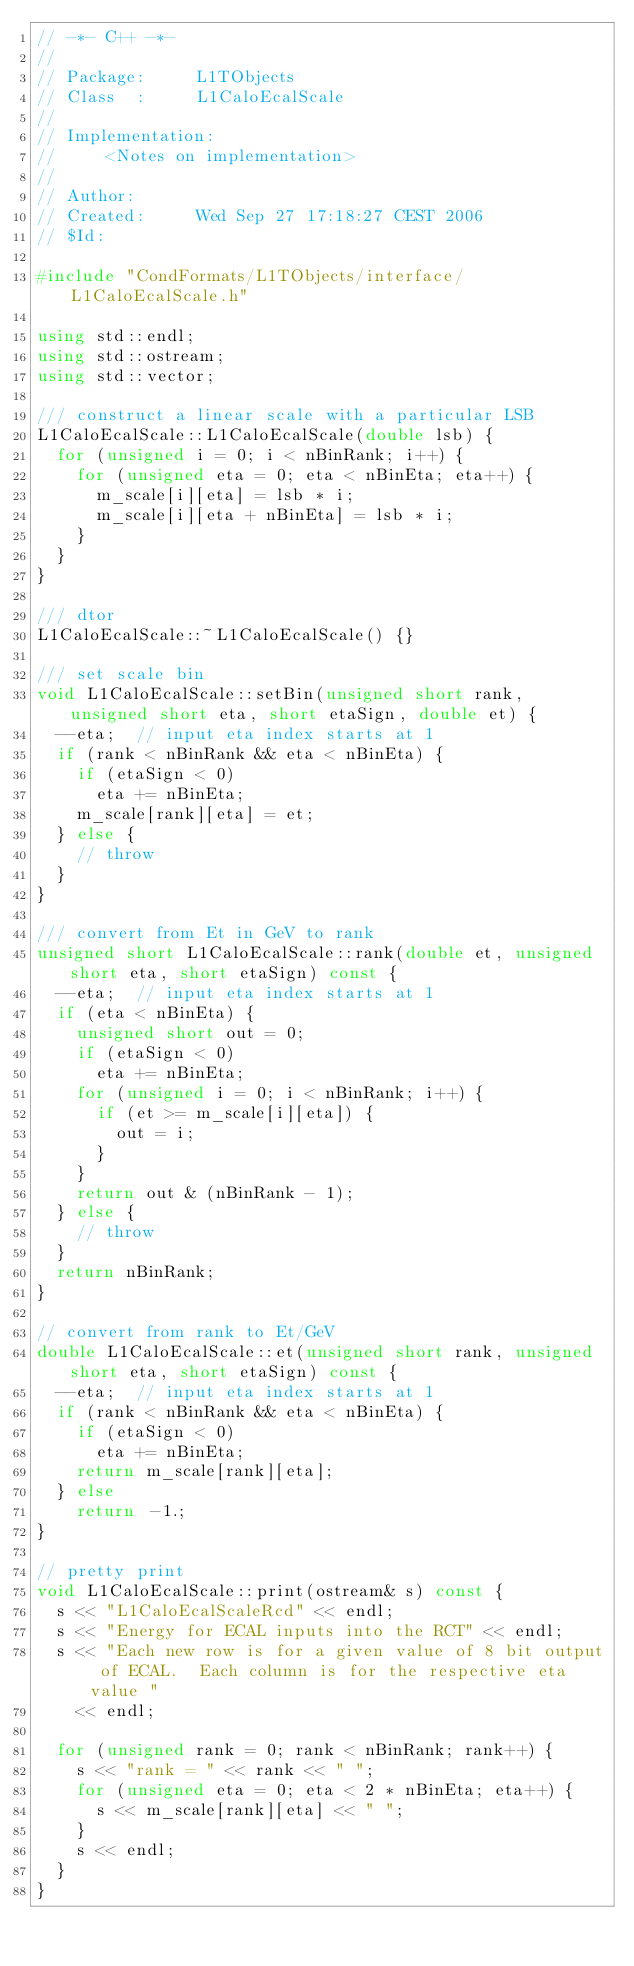Convert code to text. <code><loc_0><loc_0><loc_500><loc_500><_C++_>// -*- C++ -*-
//
// Package:     L1TObjects
// Class  :     L1CaloEcalScale
//
// Implementation:
//     <Notes on implementation>
//
// Author:
// Created:     Wed Sep 27 17:18:27 CEST 2006
// $Id:

#include "CondFormats/L1TObjects/interface/L1CaloEcalScale.h"

using std::endl;
using std::ostream;
using std::vector;

/// construct a linear scale with a particular LSB
L1CaloEcalScale::L1CaloEcalScale(double lsb) {
  for (unsigned i = 0; i < nBinRank; i++) {
    for (unsigned eta = 0; eta < nBinEta; eta++) {
      m_scale[i][eta] = lsb * i;
      m_scale[i][eta + nBinEta] = lsb * i;
    }
  }
}

/// dtor
L1CaloEcalScale::~L1CaloEcalScale() {}

/// set scale bin
void L1CaloEcalScale::setBin(unsigned short rank, unsigned short eta, short etaSign, double et) {
  --eta;  // input eta index starts at 1
  if (rank < nBinRank && eta < nBinEta) {
    if (etaSign < 0)
      eta += nBinEta;
    m_scale[rank][eta] = et;
  } else {
    // throw
  }
}

/// convert from Et in GeV to rank
unsigned short L1CaloEcalScale::rank(double et, unsigned short eta, short etaSign) const {
  --eta;  // input eta index starts at 1
  if (eta < nBinEta) {
    unsigned short out = 0;
    if (etaSign < 0)
      eta += nBinEta;
    for (unsigned i = 0; i < nBinRank; i++) {
      if (et >= m_scale[i][eta]) {
        out = i;
      }
    }
    return out & (nBinRank - 1);
  } else {
    // throw
  }
  return nBinRank;
}

// convert from rank to Et/GeV
double L1CaloEcalScale::et(unsigned short rank, unsigned short eta, short etaSign) const {
  --eta;  // input eta index starts at 1
  if (rank < nBinRank && eta < nBinEta) {
    if (etaSign < 0)
      eta += nBinEta;
    return m_scale[rank][eta];
  } else
    return -1.;
}

// pretty print
void L1CaloEcalScale::print(ostream& s) const {
  s << "L1CaloEcalScaleRcd" << endl;
  s << "Energy for ECAL inputs into the RCT" << endl;
  s << "Each new row is for a given value of 8 bit output of ECAL.  Each column is for the respective eta value "
    << endl;

  for (unsigned rank = 0; rank < nBinRank; rank++) {
    s << "rank = " << rank << " ";
    for (unsigned eta = 0; eta < 2 * nBinEta; eta++) {
      s << m_scale[rank][eta] << " ";
    }
    s << endl;
  }
}
</code> 